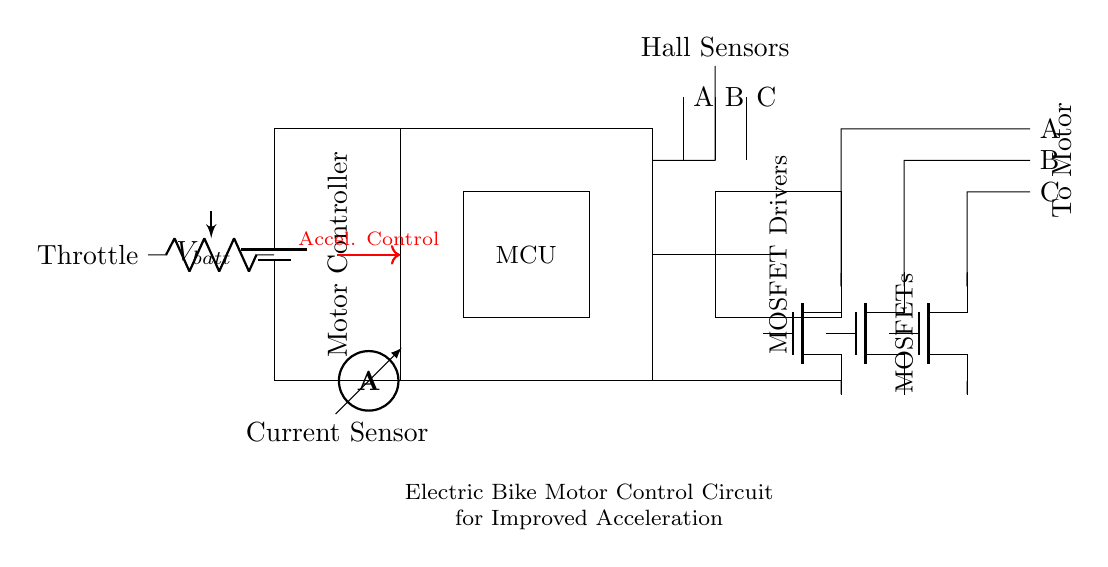What is the power source in this circuit? The power source in this circuit is a battery, indicated by the symbol at the top left labeled with V_batt. This can be identified as the component providing power to the rest of the circuit.
Answer: battery What is the role of the microcontroller? The microcontroller (MCU) is designed to process inputs from the hall sensors and manage the operations of the motor controller, indicated by its position and labeling in the diagram.
Answer: control Which component regulates the current flow to the motor? The MOSFETs are responsible for regulating the current flow to the motor, as shown in their placement between the motor controller and the motor connections in the circuit.
Answer: MOSFETs What type of sensor is used in this circuit? The sensors used in this circuit are hall sensors, which can be identified by their labeling and connection to the motor controller as inputs.
Answer: Hall sensors How is acceleration achieved in this circuit? Acceleration is achieved through the throttle input, which controls the voltage and current sent to the motor controller, as illustrated by the arrow indicating acceleration control from the throttle to the motor controller.
Answer: Throttle What type of output does the circuit provide to the motor? The output provided to the motor is a pulsed signal, which is conveyed by the connections from the MOSFETs to the motor indicated in the circuit layout.
Answer: pulsed signal How is current measured in the circuit? The current is measured with an ammeter, shown in the circuit connected in series with the main power line, indicated by its symbol and position.
Answer: ammeter 